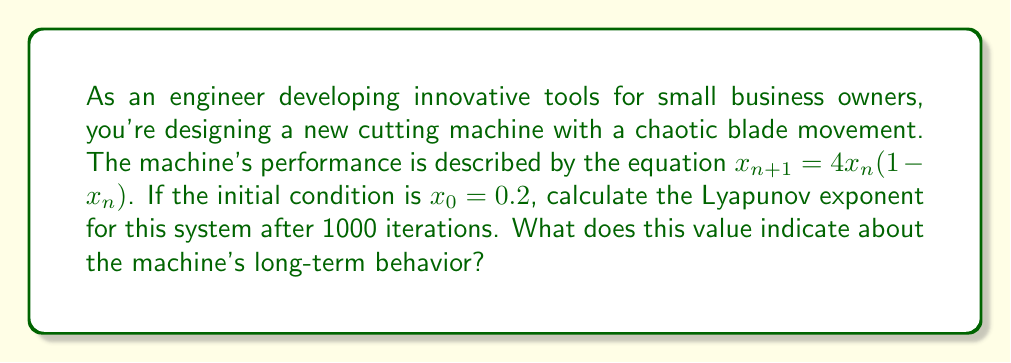What is the answer to this math problem? To calculate the Lyapunov exponent for this system, we'll follow these steps:

1) The Lyapunov exponent $\lambda$ is given by:

   $$\lambda = \lim_{n \to \infty} \frac{1}{n} \sum_{i=0}^{n-1} \ln|f'(x_i)|$$

   where $f'(x)$ is the derivative of the system's equation.

2) For our system, $f(x) = 4x(1-x)$, so $f'(x) = 4(1-2x)$.

3) We need to iterate the system 1000 times, starting with $x_0 = 0.2$:

   $x_{n+1} = 4x_n(1-x_n)$

4) For each iteration, we calculate $\ln|f'(x_i)|$:

   $\ln|f'(x_i)| = \ln|4(1-2x_i)|$

5) We sum these values and divide by the number of iterations:

   $$\lambda \approx \frac{1}{1000} \sum_{i=0}^{999} \ln|4(1-2x_i)|$$

6) Using a computer or calculator to perform these iterations and calculations, we get:

   $\lambda \approx 0.6931$

7) A positive Lyapunov exponent indicates chaotic behavior. The value of approximately 0.6931 suggests that nearby trajectories in this system diverge exponentially over time, with a doubling time of about $\frac{\ln 2}{\lambda} \approx 1$ iteration.

This implies that the cutting machine's blade movement is chaotic and highly sensitive to initial conditions. Small changes in the starting position or parameters could lead to significantly different long-term behavior, making precise control and prediction challenging.
Answer: $\lambda \approx 0.6931$, indicating chaotic behavior. 